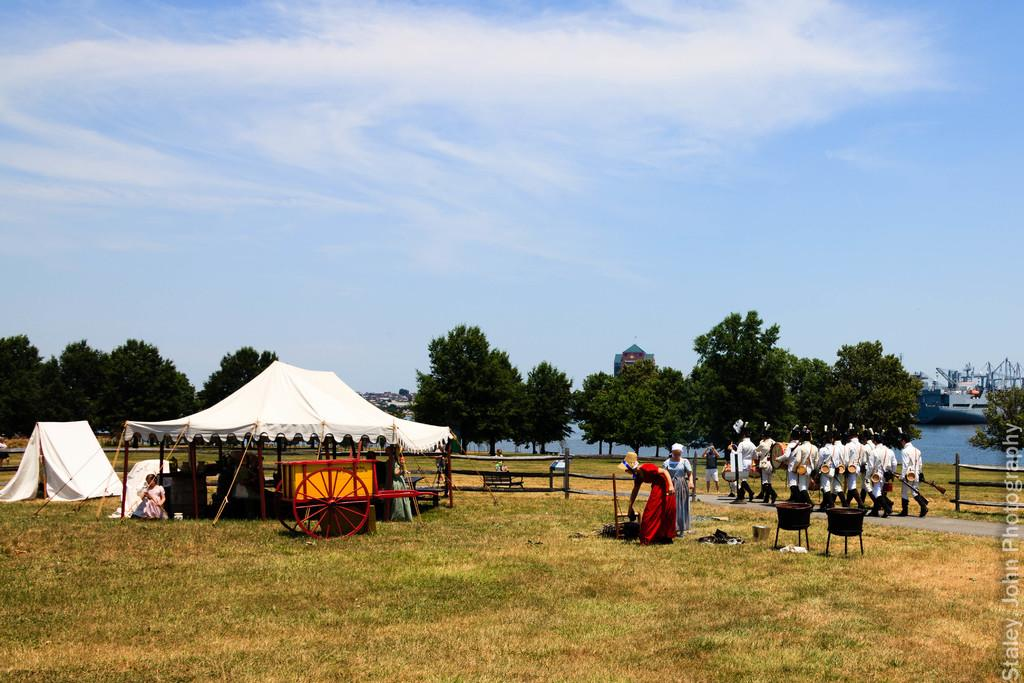What are the people in the image doing? There are people walking on the road and people on the grass in the image. What structure can be seen in the image? There is a tent in the image. What type of vegetation is visible in the image? Trees are visible around the image. What type of buildings are present in the image? Houses are present in the image. What type of spark can be seen coming from the prose in the image? There is no spark or prose present in the image. 